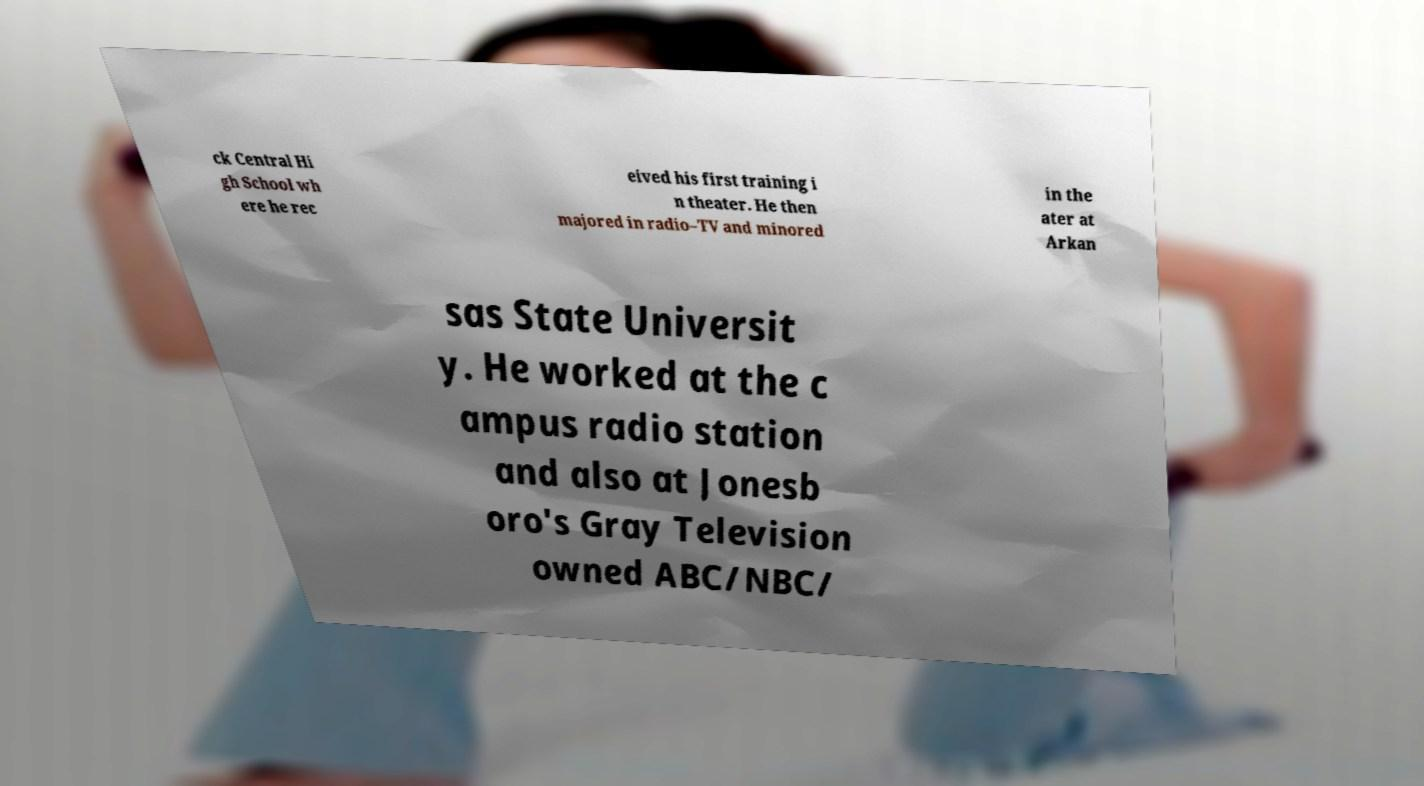What messages or text are displayed in this image? I need them in a readable, typed format. ck Central Hi gh School wh ere he rec eived his first training i n theater. He then majored in radio–TV and minored in the ater at Arkan sas State Universit y. He worked at the c ampus radio station and also at Jonesb oro's Gray Television owned ABC/NBC/ 